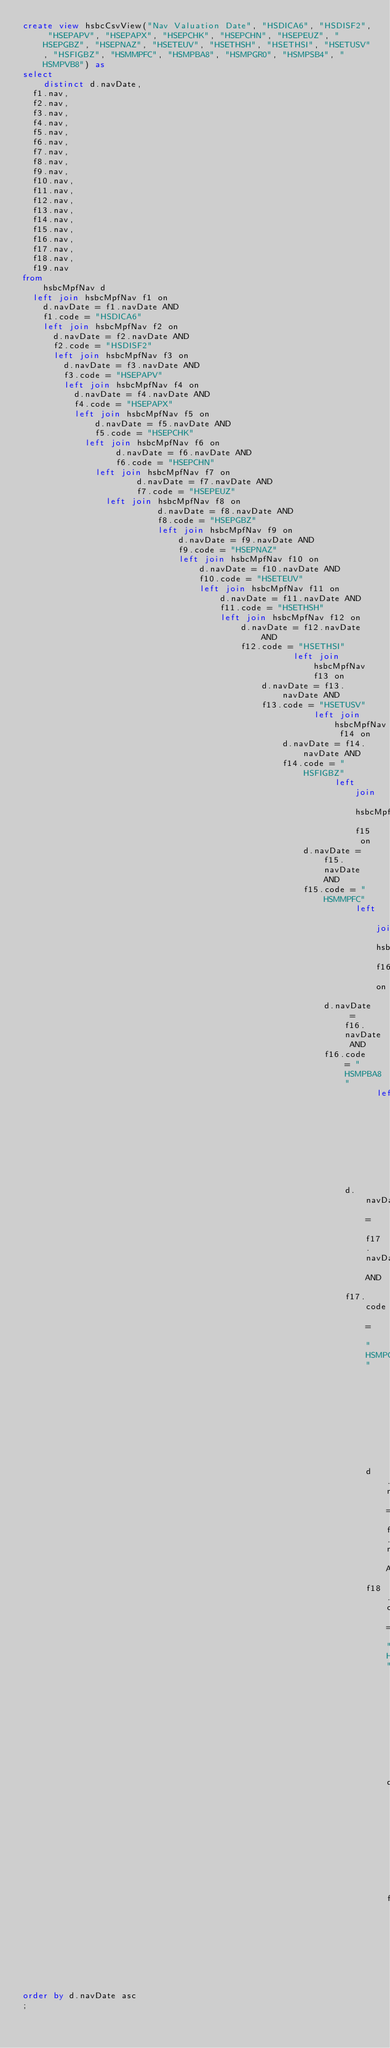<code> <loc_0><loc_0><loc_500><loc_500><_SQL_>create view hsbcCsvView("Nav Valuation Date", "HSDICA6", "HSDISF2", "HSEPAPV", "HSEPAPX", "HSEPCHK", "HSEPCHN", "HSEPEUZ", "HSEPGBZ", "HSEPNAZ", "HSETEUV", "HSETHSH", "HSETHSI", "HSETUSV", "HSFIGBZ", "HSMMPFC", "HSMPBA8", "HSMPGR0", "HSMPSB4", "HSMPVB8") as
select
    distinct d.navDate,
	f1.nav,
	f2.nav,
	f3.nav,
	f4.nav,
	f5.nav,
	f6.nav,
	f7.nav,
	f8.nav,
	f9.nav,
	f10.nav,
	f11.nav,
	f12.nav,
	f13.nav,
	f14.nav,
	f15.nav,
	f16.nav,
	f17.nav,
	f18.nav,
	f19.nav       
from
    hsbcMpfNav d
	left join hsbcMpfNav f1 on
		d.navDate = f1.navDate AND
		f1.code = "HSDICA6"
		left join hsbcMpfNav f2 on
			d.navDate = f2.navDate AND
			f2.code = "HSDISF2"
			left join hsbcMpfNav f3 on
				d.navDate = f3.navDate AND
				f3.code = "HSEPAPV"
				left join hsbcMpfNav f4 on
					d.navDate = f4.navDate AND
					f4.code = "HSEPAPX"
					left join hsbcMpfNav f5 on
					    d.navDate = f5.navDate AND
					    f5.code = "HSEPCHK"
						left join hsbcMpfNav f6 on
					        d.navDate = f6.navDate AND
					        f6.code = "HSEPCHN"
							left join hsbcMpfNav f7 on
					            d.navDate = f7.navDate AND
					            f7.code = "HSEPEUZ"
								left join hsbcMpfNav f8 on
					                d.navDate = f8.navDate AND
					                f8.code = "HSEPGBZ"
					                left join hsbcMpfNav f9 on
					                    d.navDate = f9.navDate AND
					                    f9.code = "HSEPNAZ"
					                    left join hsbcMpfNav f10 on
					                        d.navDate = f10.navDate AND
					                        f10.code = "HSETEUV"
					                        left join hsbcMpfNav f11 on
					                            d.navDate = f11.navDate AND
					                            f11.code = "HSETHSH"
					                            left join hsbcMpfNav f12 on
					                                d.navDate = f12.navDate AND
					                                f12.code = "HSETHSI"
                                                    left join hsbcMpfNav f13 on
					                                    d.navDate = f13.navDate AND
					                                    f13.code = "HSETUSV"
                                                        left join hsbcMpfNav f14 on
					                                        d.navDate = f14.navDate AND
					                                        f14.code = "HSFIGBZ"
                                                            left join hsbcMpfNav f15 on
					                                            d.navDate = f15.navDate AND
					                                            f15.code = "HSMMPFC"
                                                                left join hsbcMpfNav f16 on
					                                                d.navDate = f16.navDate AND
					                                                f16.code = "HSMPBA8"
                                                                    left join hsbcMpfNav f17 on
					                                                    d.navDate = f17.navDate AND
					                                                    f17.code = "HSMPGR0"
                                                                        left join hsbcMpfNav f18 on
					                                                        d.navDate = f18.navDate AND
					                                                        f18.code = "HSMPSB4"
                                                                            left join hsbcMpfNav f19 on
					                                                            d.navDate = f19.navDate AND
					                                                            f19.code = "HSMPVB8"
order by d.navDate asc
;</code> 